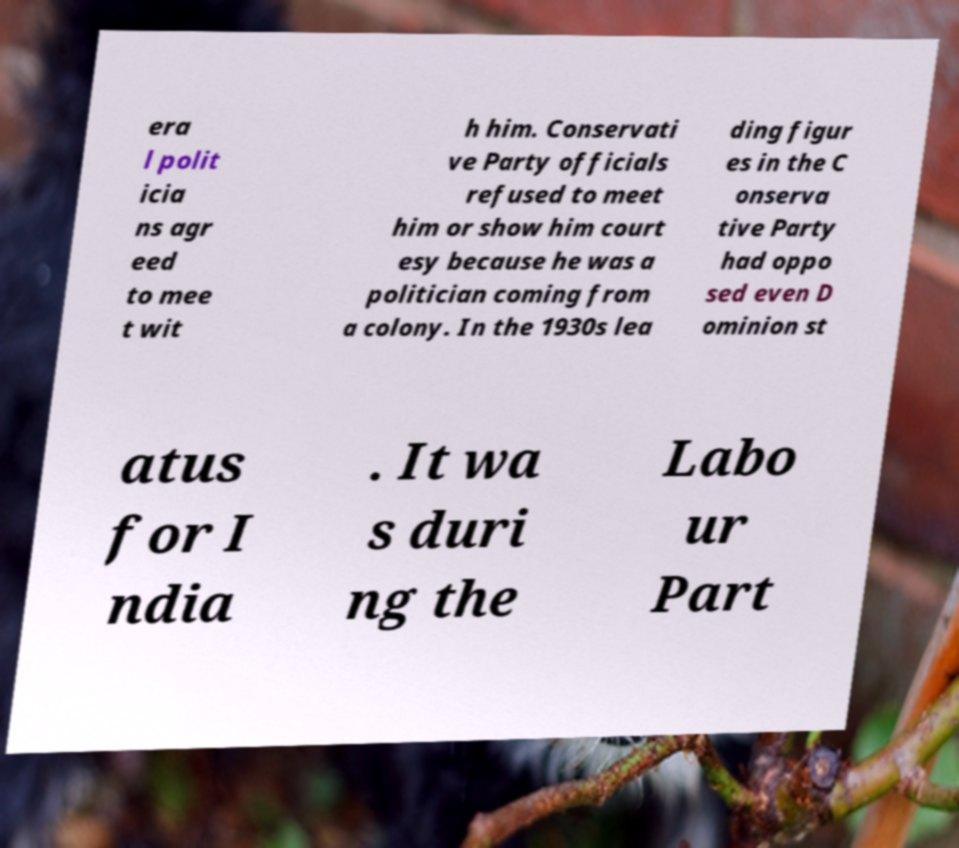Please identify and transcribe the text found in this image. era l polit icia ns agr eed to mee t wit h him. Conservati ve Party officials refused to meet him or show him court esy because he was a politician coming from a colony. In the 1930s lea ding figur es in the C onserva tive Party had oppo sed even D ominion st atus for I ndia . It wa s duri ng the Labo ur Part 